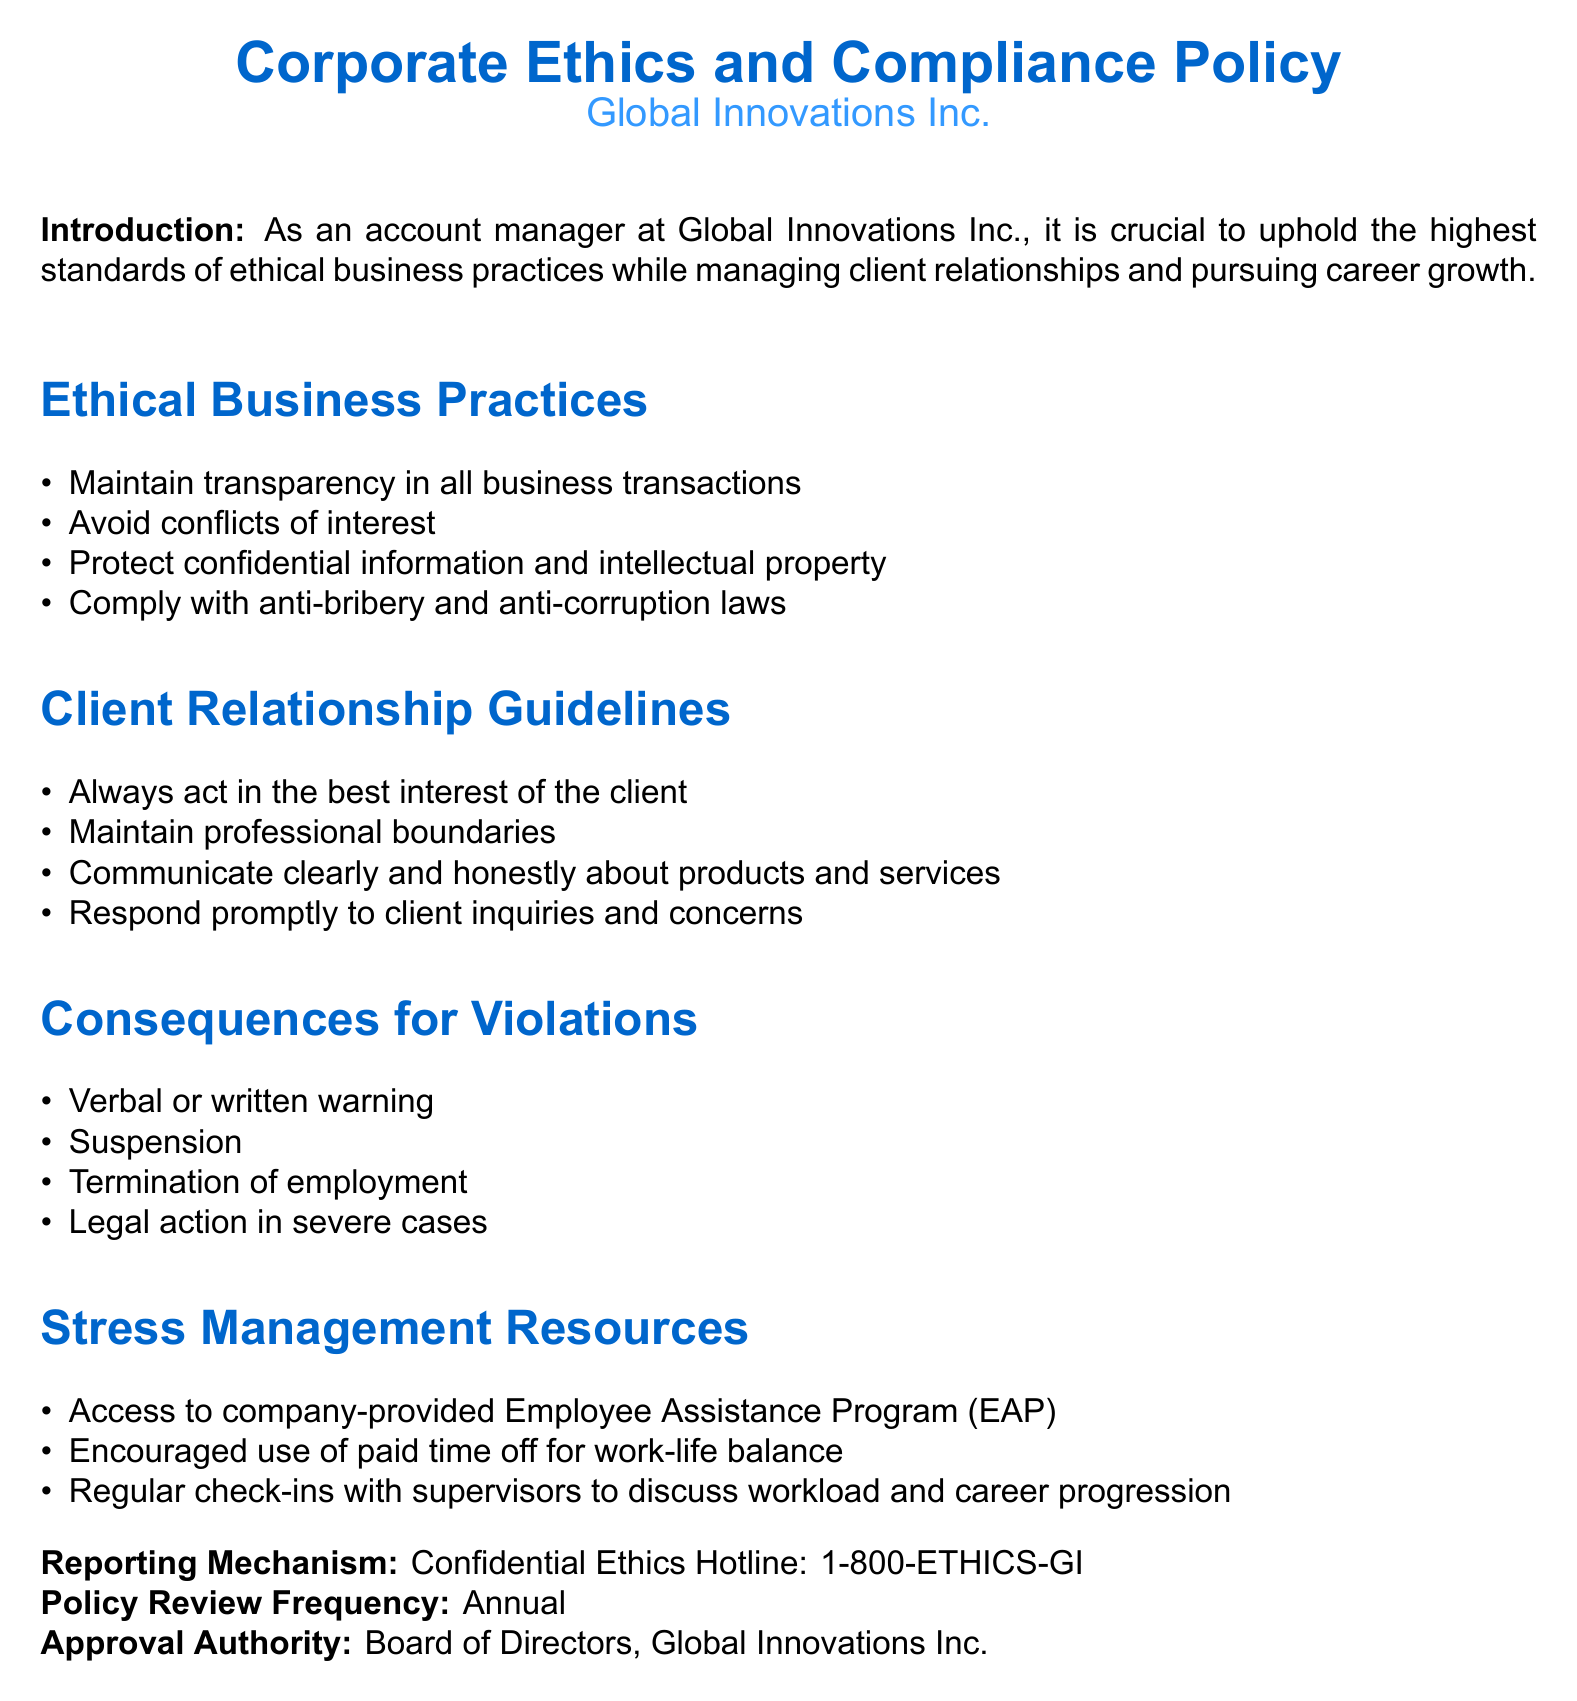What is the title of the document? The title of the document is stated prominently at the beginning.
Answer: Corporate Ethics and Compliance Policy Who is the company associated with this policy? The company name is mentioned below the title.
Answer: Global Innovations Inc What must be protected according to ethical business practices? This is a specific requirement under the ethical business practices section.
Answer: Confidential information and intellectual property What is the first guideline regarding client relationships? The first guideline listed under client relationship guidelines outlines the main priority for client management.
Answer: Always act in the best interest of the client What is the consequence for severe policy violations? This refers to the most severe action mentioned in the consequences section.
Answer: Legal action in severe cases Name one resource provided for stress management. This is found in the stress management resources section that lists available aids for employees.
Answer: Employee Assistance Program (EAP) What is the frequency of policy reviews? This detail is specified in the policy review section of the document.
Answer: Annual What type of actions can lead to suspension? This addresses the range of consequences for various levels of violations noted in the document.
Answer: Violations of the policy 